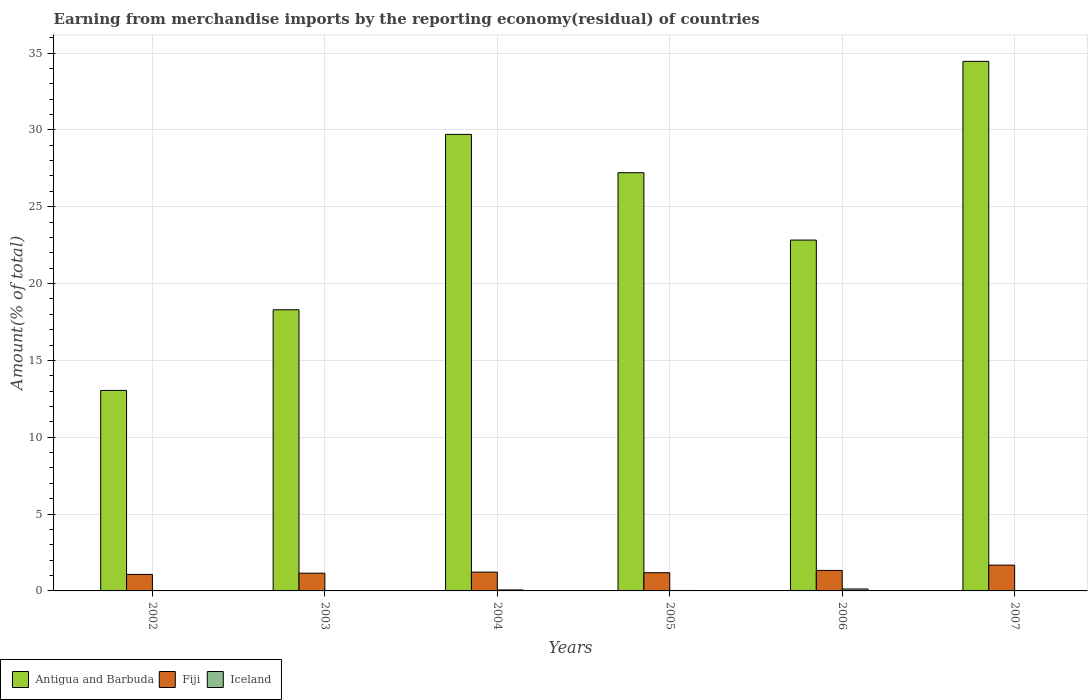Are the number of bars on each tick of the X-axis equal?
Give a very brief answer. Yes. How many bars are there on the 4th tick from the left?
Your answer should be compact. 3. How many bars are there on the 1st tick from the right?
Keep it short and to the point. 3. What is the percentage of amount earned from merchandise imports in Iceland in 2003?
Ensure brevity in your answer.  0.01. Across all years, what is the maximum percentage of amount earned from merchandise imports in Iceland?
Provide a short and direct response. 0.13. Across all years, what is the minimum percentage of amount earned from merchandise imports in Antigua and Barbuda?
Offer a terse response. 13.05. In which year was the percentage of amount earned from merchandise imports in Fiji minimum?
Give a very brief answer. 2002. What is the total percentage of amount earned from merchandise imports in Antigua and Barbuda in the graph?
Ensure brevity in your answer.  145.55. What is the difference between the percentage of amount earned from merchandise imports in Fiji in 2002 and that in 2006?
Offer a very short reply. -0.26. What is the difference between the percentage of amount earned from merchandise imports in Iceland in 2007 and the percentage of amount earned from merchandise imports in Antigua and Barbuda in 2004?
Offer a very short reply. -29.7. What is the average percentage of amount earned from merchandise imports in Fiji per year?
Provide a short and direct response. 1.28. In the year 2002, what is the difference between the percentage of amount earned from merchandise imports in Iceland and percentage of amount earned from merchandise imports in Antigua and Barbuda?
Give a very brief answer. -13.02. In how many years, is the percentage of amount earned from merchandise imports in Iceland greater than 27 %?
Give a very brief answer. 0. What is the ratio of the percentage of amount earned from merchandise imports in Iceland in 2003 to that in 2006?
Offer a very short reply. 0.05. Is the percentage of amount earned from merchandise imports in Fiji in 2002 less than that in 2005?
Make the answer very short. Yes. Is the difference between the percentage of amount earned from merchandise imports in Iceland in 2005 and 2006 greater than the difference between the percentage of amount earned from merchandise imports in Antigua and Barbuda in 2005 and 2006?
Your answer should be compact. No. What is the difference between the highest and the second highest percentage of amount earned from merchandise imports in Fiji?
Your answer should be very brief. 0.34. What is the difference between the highest and the lowest percentage of amount earned from merchandise imports in Antigua and Barbuda?
Keep it short and to the point. 21.41. In how many years, is the percentage of amount earned from merchandise imports in Iceland greater than the average percentage of amount earned from merchandise imports in Iceland taken over all years?
Your response must be concise. 2. What does the 2nd bar from the left in 2004 represents?
Ensure brevity in your answer.  Fiji. What does the 2nd bar from the right in 2002 represents?
Ensure brevity in your answer.  Fiji. Are the values on the major ticks of Y-axis written in scientific E-notation?
Provide a succinct answer. No. Does the graph contain any zero values?
Give a very brief answer. No. Does the graph contain grids?
Provide a short and direct response. Yes. Where does the legend appear in the graph?
Give a very brief answer. Bottom left. How many legend labels are there?
Your response must be concise. 3. What is the title of the graph?
Your response must be concise. Earning from merchandise imports by the reporting economy(residual) of countries. Does "Azerbaijan" appear as one of the legend labels in the graph?
Ensure brevity in your answer.  No. What is the label or title of the Y-axis?
Offer a very short reply. Amount(% of total). What is the Amount(% of total) of Antigua and Barbuda in 2002?
Keep it short and to the point. 13.05. What is the Amount(% of total) in Fiji in 2002?
Keep it short and to the point. 1.07. What is the Amount(% of total) in Iceland in 2002?
Keep it short and to the point. 0.02. What is the Amount(% of total) in Antigua and Barbuda in 2003?
Give a very brief answer. 18.29. What is the Amount(% of total) of Fiji in 2003?
Make the answer very short. 1.15. What is the Amount(% of total) in Iceland in 2003?
Keep it short and to the point. 0.01. What is the Amount(% of total) of Antigua and Barbuda in 2004?
Your response must be concise. 29.71. What is the Amount(% of total) in Fiji in 2004?
Offer a very short reply. 1.22. What is the Amount(% of total) in Iceland in 2004?
Provide a short and direct response. 0.06. What is the Amount(% of total) of Antigua and Barbuda in 2005?
Ensure brevity in your answer.  27.21. What is the Amount(% of total) in Fiji in 2005?
Make the answer very short. 1.19. What is the Amount(% of total) in Iceland in 2005?
Ensure brevity in your answer.  0.03. What is the Amount(% of total) of Antigua and Barbuda in 2006?
Give a very brief answer. 22.83. What is the Amount(% of total) in Fiji in 2006?
Your answer should be very brief. 1.33. What is the Amount(% of total) of Iceland in 2006?
Make the answer very short. 0.13. What is the Amount(% of total) of Antigua and Barbuda in 2007?
Offer a terse response. 34.46. What is the Amount(% of total) of Fiji in 2007?
Give a very brief answer. 1.68. What is the Amount(% of total) of Iceland in 2007?
Provide a succinct answer. 0.01. Across all years, what is the maximum Amount(% of total) in Antigua and Barbuda?
Give a very brief answer. 34.46. Across all years, what is the maximum Amount(% of total) in Fiji?
Provide a succinct answer. 1.68. Across all years, what is the maximum Amount(% of total) in Iceland?
Keep it short and to the point. 0.13. Across all years, what is the minimum Amount(% of total) of Antigua and Barbuda?
Your answer should be compact. 13.05. Across all years, what is the minimum Amount(% of total) in Fiji?
Your response must be concise. 1.07. Across all years, what is the minimum Amount(% of total) of Iceland?
Your answer should be very brief. 0.01. What is the total Amount(% of total) in Antigua and Barbuda in the graph?
Provide a short and direct response. 145.55. What is the total Amount(% of total) in Fiji in the graph?
Provide a succinct answer. 7.65. What is the total Amount(% of total) of Iceland in the graph?
Your response must be concise. 0.26. What is the difference between the Amount(% of total) of Antigua and Barbuda in 2002 and that in 2003?
Your answer should be compact. -5.25. What is the difference between the Amount(% of total) in Fiji in 2002 and that in 2003?
Keep it short and to the point. -0.08. What is the difference between the Amount(% of total) in Iceland in 2002 and that in 2003?
Make the answer very short. 0.02. What is the difference between the Amount(% of total) in Antigua and Barbuda in 2002 and that in 2004?
Offer a very short reply. -16.66. What is the difference between the Amount(% of total) of Fiji in 2002 and that in 2004?
Provide a succinct answer. -0.15. What is the difference between the Amount(% of total) in Iceland in 2002 and that in 2004?
Keep it short and to the point. -0.04. What is the difference between the Amount(% of total) in Antigua and Barbuda in 2002 and that in 2005?
Your answer should be very brief. -14.17. What is the difference between the Amount(% of total) in Fiji in 2002 and that in 2005?
Your response must be concise. -0.11. What is the difference between the Amount(% of total) in Iceland in 2002 and that in 2005?
Offer a very short reply. -0.01. What is the difference between the Amount(% of total) in Antigua and Barbuda in 2002 and that in 2006?
Provide a short and direct response. -9.78. What is the difference between the Amount(% of total) of Fiji in 2002 and that in 2006?
Make the answer very short. -0.26. What is the difference between the Amount(% of total) of Iceland in 2002 and that in 2006?
Provide a succinct answer. -0.1. What is the difference between the Amount(% of total) in Antigua and Barbuda in 2002 and that in 2007?
Offer a very short reply. -21.41. What is the difference between the Amount(% of total) in Fiji in 2002 and that in 2007?
Provide a short and direct response. -0.6. What is the difference between the Amount(% of total) of Iceland in 2002 and that in 2007?
Keep it short and to the point. 0.01. What is the difference between the Amount(% of total) in Antigua and Barbuda in 2003 and that in 2004?
Your answer should be compact. -11.41. What is the difference between the Amount(% of total) in Fiji in 2003 and that in 2004?
Offer a very short reply. -0.07. What is the difference between the Amount(% of total) of Iceland in 2003 and that in 2004?
Your response must be concise. -0.06. What is the difference between the Amount(% of total) of Antigua and Barbuda in 2003 and that in 2005?
Offer a very short reply. -8.92. What is the difference between the Amount(% of total) of Fiji in 2003 and that in 2005?
Your answer should be very brief. -0.03. What is the difference between the Amount(% of total) of Iceland in 2003 and that in 2005?
Your answer should be very brief. -0.02. What is the difference between the Amount(% of total) in Antigua and Barbuda in 2003 and that in 2006?
Offer a very short reply. -4.54. What is the difference between the Amount(% of total) in Fiji in 2003 and that in 2006?
Make the answer very short. -0.18. What is the difference between the Amount(% of total) in Iceland in 2003 and that in 2006?
Offer a very short reply. -0.12. What is the difference between the Amount(% of total) in Antigua and Barbuda in 2003 and that in 2007?
Offer a very short reply. -16.16. What is the difference between the Amount(% of total) of Fiji in 2003 and that in 2007?
Ensure brevity in your answer.  -0.52. What is the difference between the Amount(% of total) of Iceland in 2003 and that in 2007?
Your response must be concise. -0. What is the difference between the Amount(% of total) in Antigua and Barbuda in 2004 and that in 2005?
Offer a terse response. 2.49. What is the difference between the Amount(% of total) of Fiji in 2004 and that in 2005?
Ensure brevity in your answer.  0.04. What is the difference between the Amount(% of total) in Iceland in 2004 and that in 2005?
Your answer should be very brief. 0.03. What is the difference between the Amount(% of total) of Antigua and Barbuda in 2004 and that in 2006?
Offer a terse response. 6.88. What is the difference between the Amount(% of total) in Fiji in 2004 and that in 2006?
Provide a succinct answer. -0.11. What is the difference between the Amount(% of total) in Iceland in 2004 and that in 2006?
Provide a succinct answer. -0.06. What is the difference between the Amount(% of total) of Antigua and Barbuda in 2004 and that in 2007?
Offer a very short reply. -4.75. What is the difference between the Amount(% of total) of Fiji in 2004 and that in 2007?
Provide a short and direct response. -0.45. What is the difference between the Amount(% of total) of Iceland in 2004 and that in 2007?
Provide a short and direct response. 0.05. What is the difference between the Amount(% of total) in Antigua and Barbuda in 2005 and that in 2006?
Your answer should be very brief. 4.38. What is the difference between the Amount(% of total) in Fiji in 2005 and that in 2006?
Your answer should be very brief. -0.15. What is the difference between the Amount(% of total) in Iceland in 2005 and that in 2006?
Keep it short and to the point. -0.1. What is the difference between the Amount(% of total) in Antigua and Barbuda in 2005 and that in 2007?
Provide a short and direct response. -7.24. What is the difference between the Amount(% of total) of Fiji in 2005 and that in 2007?
Offer a terse response. -0.49. What is the difference between the Amount(% of total) of Iceland in 2005 and that in 2007?
Keep it short and to the point. 0.02. What is the difference between the Amount(% of total) in Antigua and Barbuda in 2006 and that in 2007?
Provide a short and direct response. -11.63. What is the difference between the Amount(% of total) of Fiji in 2006 and that in 2007?
Your response must be concise. -0.34. What is the difference between the Amount(% of total) of Iceland in 2006 and that in 2007?
Give a very brief answer. 0.12. What is the difference between the Amount(% of total) in Antigua and Barbuda in 2002 and the Amount(% of total) in Fiji in 2003?
Ensure brevity in your answer.  11.89. What is the difference between the Amount(% of total) of Antigua and Barbuda in 2002 and the Amount(% of total) of Iceland in 2003?
Offer a terse response. 13.04. What is the difference between the Amount(% of total) of Fiji in 2002 and the Amount(% of total) of Iceland in 2003?
Offer a very short reply. 1.07. What is the difference between the Amount(% of total) in Antigua and Barbuda in 2002 and the Amount(% of total) in Fiji in 2004?
Offer a terse response. 11.82. What is the difference between the Amount(% of total) in Antigua and Barbuda in 2002 and the Amount(% of total) in Iceland in 2004?
Give a very brief answer. 12.98. What is the difference between the Amount(% of total) of Fiji in 2002 and the Amount(% of total) of Iceland in 2004?
Give a very brief answer. 1.01. What is the difference between the Amount(% of total) of Antigua and Barbuda in 2002 and the Amount(% of total) of Fiji in 2005?
Ensure brevity in your answer.  11.86. What is the difference between the Amount(% of total) in Antigua and Barbuda in 2002 and the Amount(% of total) in Iceland in 2005?
Your response must be concise. 13.02. What is the difference between the Amount(% of total) of Fiji in 2002 and the Amount(% of total) of Iceland in 2005?
Give a very brief answer. 1.05. What is the difference between the Amount(% of total) of Antigua and Barbuda in 2002 and the Amount(% of total) of Fiji in 2006?
Provide a succinct answer. 11.71. What is the difference between the Amount(% of total) in Antigua and Barbuda in 2002 and the Amount(% of total) in Iceland in 2006?
Provide a succinct answer. 12.92. What is the difference between the Amount(% of total) in Fiji in 2002 and the Amount(% of total) in Iceland in 2006?
Offer a very short reply. 0.95. What is the difference between the Amount(% of total) of Antigua and Barbuda in 2002 and the Amount(% of total) of Fiji in 2007?
Make the answer very short. 11.37. What is the difference between the Amount(% of total) of Antigua and Barbuda in 2002 and the Amount(% of total) of Iceland in 2007?
Provide a succinct answer. 13.04. What is the difference between the Amount(% of total) in Fiji in 2002 and the Amount(% of total) in Iceland in 2007?
Keep it short and to the point. 1.07. What is the difference between the Amount(% of total) in Antigua and Barbuda in 2003 and the Amount(% of total) in Fiji in 2004?
Ensure brevity in your answer.  17.07. What is the difference between the Amount(% of total) in Antigua and Barbuda in 2003 and the Amount(% of total) in Iceland in 2004?
Your response must be concise. 18.23. What is the difference between the Amount(% of total) of Fiji in 2003 and the Amount(% of total) of Iceland in 2004?
Offer a terse response. 1.09. What is the difference between the Amount(% of total) in Antigua and Barbuda in 2003 and the Amount(% of total) in Fiji in 2005?
Provide a short and direct response. 17.11. What is the difference between the Amount(% of total) of Antigua and Barbuda in 2003 and the Amount(% of total) of Iceland in 2005?
Offer a very short reply. 18.27. What is the difference between the Amount(% of total) of Fiji in 2003 and the Amount(% of total) of Iceland in 2005?
Make the answer very short. 1.13. What is the difference between the Amount(% of total) in Antigua and Barbuda in 2003 and the Amount(% of total) in Fiji in 2006?
Give a very brief answer. 16.96. What is the difference between the Amount(% of total) of Antigua and Barbuda in 2003 and the Amount(% of total) of Iceland in 2006?
Make the answer very short. 18.17. What is the difference between the Amount(% of total) in Fiji in 2003 and the Amount(% of total) in Iceland in 2006?
Offer a very short reply. 1.03. What is the difference between the Amount(% of total) of Antigua and Barbuda in 2003 and the Amount(% of total) of Fiji in 2007?
Offer a terse response. 16.62. What is the difference between the Amount(% of total) of Antigua and Barbuda in 2003 and the Amount(% of total) of Iceland in 2007?
Keep it short and to the point. 18.29. What is the difference between the Amount(% of total) in Fiji in 2003 and the Amount(% of total) in Iceland in 2007?
Offer a terse response. 1.15. What is the difference between the Amount(% of total) of Antigua and Barbuda in 2004 and the Amount(% of total) of Fiji in 2005?
Your answer should be very brief. 28.52. What is the difference between the Amount(% of total) in Antigua and Barbuda in 2004 and the Amount(% of total) in Iceland in 2005?
Your response must be concise. 29.68. What is the difference between the Amount(% of total) of Fiji in 2004 and the Amount(% of total) of Iceland in 2005?
Your response must be concise. 1.19. What is the difference between the Amount(% of total) in Antigua and Barbuda in 2004 and the Amount(% of total) in Fiji in 2006?
Ensure brevity in your answer.  28.37. What is the difference between the Amount(% of total) in Antigua and Barbuda in 2004 and the Amount(% of total) in Iceland in 2006?
Your answer should be compact. 29.58. What is the difference between the Amount(% of total) of Fiji in 2004 and the Amount(% of total) of Iceland in 2006?
Provide a short and direct response. 1.1. What is the difference between the Amount(% of total) in Antigua and Barbuda in 2004 and the Amount(% of total) in Fiji in 2007?
Provide a short and direct response. 28.03. What is the difference between the Amount(% of total) of Antigua and Barbuda in 2004 and the Amount(% of total) of Iceland in 2007?
Your response must be concise. 29.7. What is the difference between the Amount(% of total) in Fiji in 2004 and the Amount(% of total) in Iceland in 2007?
Offer a very short reply. 1.21. What is the difference between the Amount(% of total) of Antigua and Barbuda in 2005 and the Amount(% of total) of Fiji in 2006?
Provide a short and direct response. 25.88. What is the difference between the Amount(% of total) in Antigua and Barbuda in 2005 and the Amount(% of total) in Iceland in 2006?
Provide a succinct answer. 27.09. What is the difference between the Amount(% of total) of Fiji in 2005 and the Amount(% of total) of Iceland in 2006?
Your answer should be very brief. 1.06. What is the difference between the Amount(% of total) in Antigua and Barbuda in 2005 and the Amount(% of total) in Fiji in 2007?
Your answer should be very brief. 25.54. What is the difference between the Amount(% of total) in Antigua and Barbuda in 2005 and the Amount(% of total) in Iceland in 2007?
Give a very brief answer. 27.21. What is the difference between the Amount(% of total) in Fiji in 2005 and the Amount(% of total) in Iceland in 2007?
Offer a terse response. 1.18. What is the difference between the Amount(% of total) of Antigua and Barbuda in 2006 and the Amount(% of total) of Fiji in 2007?
Make the answer very short. 21.15. What is the difference between the Amount(% of total) in Antigua and Barbuda in 2006 and the Amount(% of total) in Iceland in 2007?
Give a very brief answer. 22.82. What is the difference between the Amount(% of total) of Fiji in 2006 and the Amount(% of total) of Iceland in 2007?
Ensure brevity in your answer.  1.33. What is the average Amount(% of total) in Antigua and Barbuda per year?
Your response must be concise. 24.26. What is the average Amount(% of total) in Fiji per year?
Your answer should be very brief. 1.27. What is the average Amount(% of total) in Iceland per year?
Offer a terse response. 0.04. In the year 2002, what is the difference between the Amount(% of total) of Antigua and Barbuda and Amount(% of total) of Fiji?
Provide a short and direct response. 11.97. In the year 2002, what is the difference between the Amount(% of total) of Antigua and Barbuda and Amount(% of total) of Iceland?
Provide a short and direct response. 13.02. In the year 2002, what is the difference between the Amount(% of total) of Fiji and Amount(% of total) of Iceland?
Make the answer very short. 1.05. In the year 2003, what is the difference between the Amount(% of total) in Antigua and Barbuda and Amount(% of total) in Fiji?
Your answer should be very brief. 17.14. In the year 2003, what is the difference between the Amount(% of total) in Antigua and Barbuda and Amount(% of total) in Iceland?
Provide a succinct answer. 18.29. In the year 2003, what is the difference between the Amount(% of total) in Fiji and Amount(% of total) in Iceland?
Your response must be concise. 1.15. In the year 2004, what is the difference between the Amount(% of total) in Antigua and Barbuda and Amount(% of total) in Fiji?
Your answer should be very brief. 28.48. In the year 2004, what is the difference between the Amount(% of total) of Antigua and Barbuda and Amount(% of total) of Iceland?
Your answer should be compact. 29.64. In the year 2004, what is the difference between the Amount(% of total) of Fiji and Amount(% of total) of Iceland?
Ensure brevity in your answer.  1.16. In the year 2005, what is the difference between the Amount(% of total) of Antigua and Barbuda and Amount(% of total) of Fiji?
Provide a short and direct response. 26.03. In the year 2005, what is the difference between the Amount(% of total) in Antigua and Barbuda and Amount(% of total) in Iceland?
Ensure brevity in your answer.  27.19. In the year 2005, what is the difference between the Amount(% of total) in Fiji and Amount(% of total) in Iceland?
Your answer should be compact. 1.16. In the year 2006, what is the difference between the Amount(% of total) in Antigua and Barbuda and Amount(% of total) in Fiji?
Ensure brevity in your answer.  21.5. In the year 2006, what is the difference between the Amount(% of total) in Antigua and Barbuda and Amount(% of total) in Iceland?
Give a very brief answer. 22.7. In the year 2006, what is the difference between the Amount(% of total) of Fiji and Amount(% of total) of Iceland?
Offer a terse response. 1.21. In the year 2007, what is the difference between the Amount(% of total) of Antigua and Barbuda and Amount(% of total) of Fiji?
Provide a short and direct response. 32.78. In the year 2007, what is the difference between the Amount(% of total) in Antigua and Barbuda and Amount(% of total) in Iceland?
Your response must be concise. 34.45. In the year 2007, what is the difference between the Amount(% of total) in Fiji and Amount(% of total) in Iceland?
Make the answer very short. 1.67. What is the ratio of the Amount(% of total) in Antigua and Barbuda in 2002 to that in 2003?
Your response must be concise. 0.71. What is the ratio of the Amount(% of total) of Fiji in 2002 to that in 2003?
Give a very brief answer. 0.93. What is the ratio of the Amount(% of total) of Iceland in 2002 to that in 2003?
Ensure brevity in your answer.  3.36. What is the ratio of the Amount(% of total) in Antigua and Barbuda in 2002 to that in 2004?
Provide a succinct answer. 0.44. What is the ratio of the Amount(% of total) in Fiji in 2002 to that in 2004?
Your answer should be very brief. 0.88. What is the ratio of the Amount(% of total) of Iceland in 2002 to that in 2004?
Make the answer very short. 0.35. What is the ratio of the Amount(% of total) in Antigua and Barbuda in 2002 to that in 2005?
Offer a terse response. 0.48. What is the ratio of the Amount(% of total) of Fiji in 2002 to that in 2005?
Offer a very short reply. 0.91. What is the ratio of the Amount(% of total) in Iceland in 2002 to that in 2005?
Give a very brief answer. 0.76. What is the ratio of the Amount(% of total) in Fiji in 2002 to that in 2006?
Your response must be concise. 0.81. What is the ratio of the Amount(% of total) in Iceland in 2002 to that in 2006?
Provide a short and direct response. 0.17. What is the ratio of the Amount(% of total) of Antigua and Barbuda in 2002 to that in 2007?
Your answer should be compact. 0.38. What is the ratio of the Amount(% of total) in Fiji in 2002 to that in 2007?
Your answer should be compact. 0.64. What is the ratio of the Amount(% of total) in Iceland in 2002 to that in 2007?
Give a very brief answer. 2.58. What is the ratio of the Amount(% of total) in Antigua and Barbuda in 2003 to that in 2004?
Ensure brevity in your answer.  0.62. What is the ratio of the Amount(% of total) in Fiji in 2003 to that in 2004?
Provide a short and direct response. 0.94. What is the ratio of the Amount(% of total) of Iceland in 2003 to that in 2004?
Offer a very short reply. 0.1. What is the ratio of the Amount(% of total) in Antigua and Barbuda in 2003 to that in 2005?
Your answer should be very brief. 0.67. What is the ratio of the Amount(% of total) in Fiji in 2003 to that in 2005?
Keep it short and to the point. 0.97. What is the ratio of the Amount(% of total) of Iceland in 2003 to that in 2005?
Your answer should be compact. 0.23. What is the ratio of the Amount(% of total) in Antigua and Barbuda in 2003 to that in 2006?
Your response must be concise. 0.8. What is the ratio of the Amount(% of total) of Fiji in 2003 to that in 2006?
Your response must be concise. 0.87. What is the ratio of the Amount(% of total) in Iceland in 2003 to that in 2006?
Your answer should be compact. 0.05. What is the ratio of the Amount(% of total) in Antigua and Barbuda in 2003 to that in 2007?
Ensure brevity in your answer.  0.53. What is the ratio of the Amount(% of total) in Fiji in 2003 to that in 2007?
Your response must be concise. 0.69. What is the ratio of the Amount(% of total) of Iceland in 2003 to that in 2007?
Offer a terse response. 0.77. What is the ratio of the Amount(% of total) of Antigua and Barbuda in 2004 to that in 2005?
Provide a succinct answer. 1.09. What is the ratio of the Amount(% of total) of Fiji in 2004 to that in 2005?
Your answer should be very brief. 1.03. What is the ratio of the Amount(% of total) of Iceland in 2004 to that in 2005?
Your response must be concise. 2.21. What is the ratio of the Amount(% of total) in Antigua and Barbuda in 2004 to that in 2006?
Keep it short and to the point. 1.3. What is the ratio of the Amount(% of total) of Fiji in 2004 to that in 2006?
Your answer should be very brief. 0.92. What is the ratio of the Amount(% of total) in Iceland in 2004 to that in 2006?
Offer a very short reply. 0.5. What is the ratio of the Amount(% of total) of Antigua and Barbuda in 2004 to that in 2007?
Provide a short and direct response. 0.86. What is the ratio of the Amount(% of total) in Fiji in 2004 to that in 2007?
Your answer should be very brief. 0.73. What is the ratio of the Amount(% of total) of Iceland in 2004 to that in 2007?
Your answer should be compact. 7.44. What is the ratio of the Amount(% of total) in Antigua and Barbuda in 2005 to that in 2006?
Offer a terse response. 1.19. What is the ratio of the Amount(% of total) in Fiji in 2005 to that in 2006?
Offer a very short reply. 0.89. What is the ratio of the Amount(% of total) in Iceland in 2005 to that in 2006?
Your response must be concise. 0.23. What is the ratio of the Amount(% of total) of Antigua and Barbuda in 2005 to that in 2007?
Offer a terse response. 0.79. What is the ratio of the Amount(% of total) in Fiji in 2005 to that in 2007?
Provide a succinct answer. 0.71. What is the ratio of the Amount(% of total) of Iceland in 2005 to that in 2007?
Your response must be concise. 3.37. What is the ratio of the Amount(% of total) in Antigua and Barbuda in 2006 to that in 2007?
Keep it short and to the point. 0.66. What is the ratio of the Amount(% of total) of Fiji in 2006 to that in 2007?
Provide a succinct answer. 0.8. What is the ratio of the Amount(% of total) in Iceland in 2006 to that in 2007?
Offer a terse response. 14.88. What is the difference between the highest and the second highest Amount(% of total) of Antigua and Barbuda?
Give a very brief answer. 4.75. What is the difference between the highest and the second highest Amount(% of total) in Fiji?
Provide a succinct answer. 0.34. What is the difference between the highest and the second highest Amount(% of total) of Iceland?
Your answer should be very brief. 0.06. What is the difference between the highest and the lowest Amount(% of total) in Antigua and Barbuda?
Your response must be concise. 21.41. What is the difference between the highest and the lowest Amount(% of total) in Fiji?
Your answer should be compact. 0.6. What is the difference between the highest and the lowest Amount(% of total) in Iceland?
Ensure brevity in your answer.  0.12. 